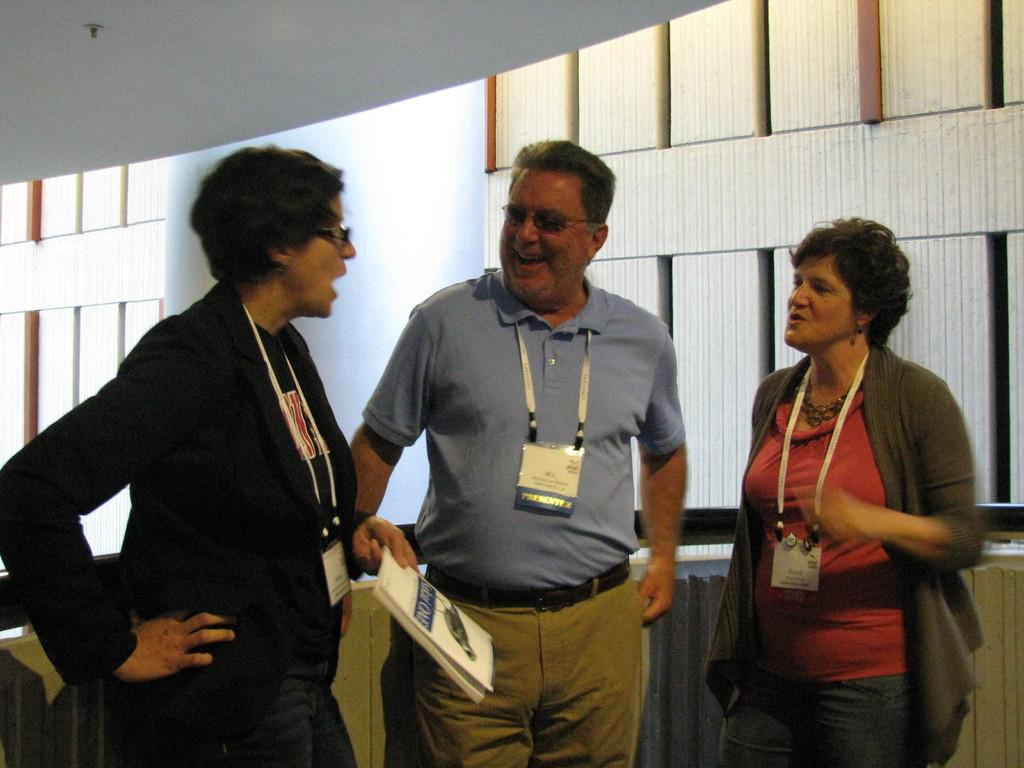How many people are in the image? There is a group of persons standing in the image. What is one of the persons holding in her hand? One woman is holding a book in her hand. What can be seen in the background of the image? There are windows and a wall visible in the background of the image. What type of rabbit can be seen hopping around in the image? There is no rabbit present in the image. What is the woman doing with the book in the image? The woman is holding the book in her hand, but there is no indication of what she is doing with it. 